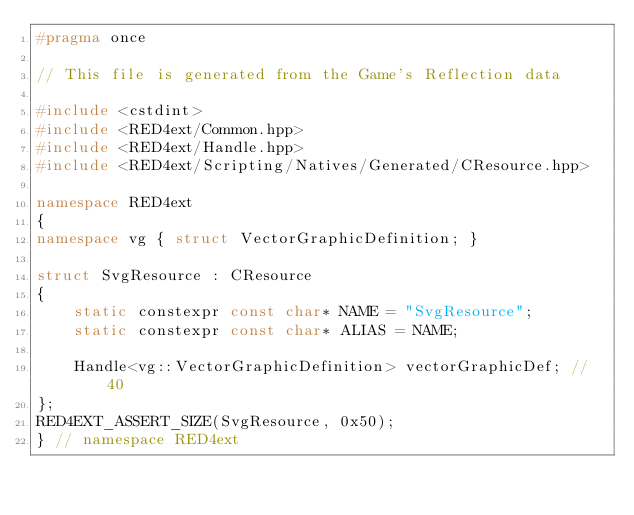<code> <loc_0><loc_0><loc_500><loc_500><_C++_>#pragma once

// This file is generated from the Game's Reflection data

#include <cstdint>
#include <RED4ext/Common.hpp>
#include <RED4ext/Handle.hpp>
#include <RED4ext/Scripting/Natives/Generated/CResource.hpp>

namespace RED4ext
{
namespace vg { struct VectorGraphicDefinition; }

struct SvgResource : CResource
{
    static constexpr const char* NAME = "SvgResource";
    static constexpr const char* ALIAS = NAME;

    Handle<vg::VectorGraphicDefinition> vectorGraphicDef; // 40
};
RED4EXT_ASSERT_SIZE(SvgResource, 0x50);
} // namespace RED4ext
</code> 